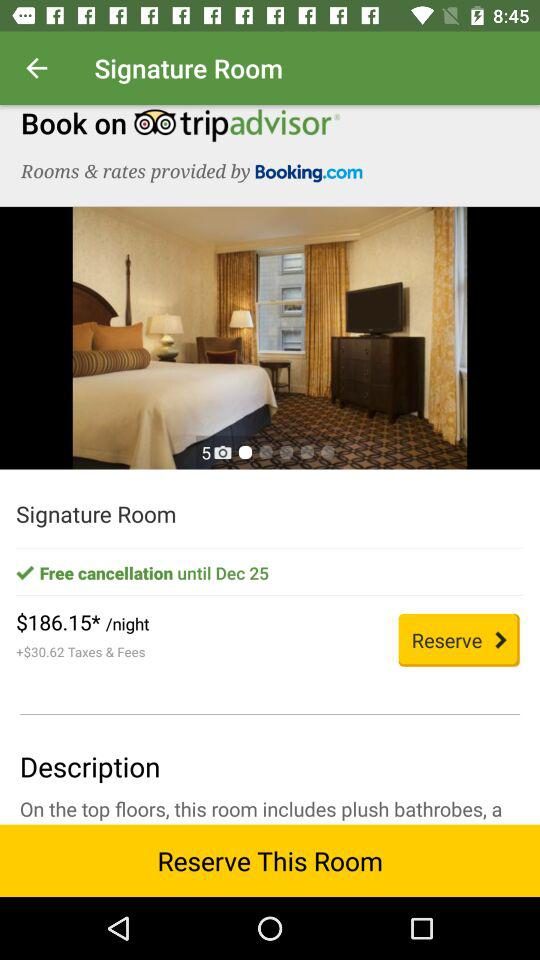How much is the price per night? The price per night is $186.15. 